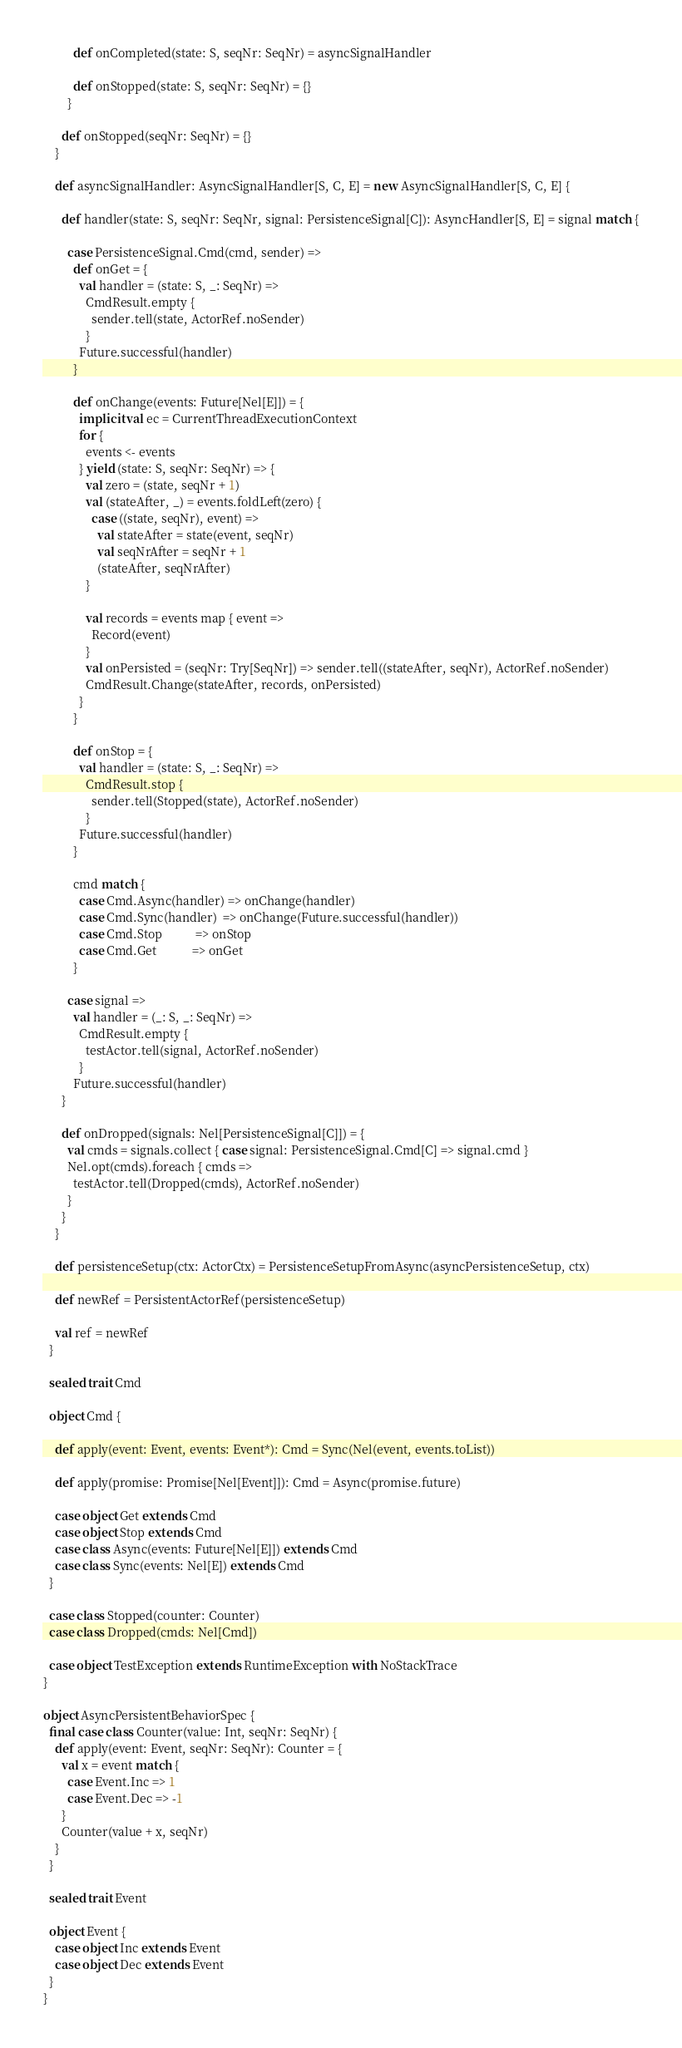<code> <loc_0><loc_0><loc_500><loc_500><_Scala_>          def onCompleted(state: S, seqNr: SeqNr) = asyncSignalHandler

          def onStopped(state: S, seqNr: SeqNr) = {}
        }

      def onStopped(seqNr: SeqNr) = {}
    }

    def asyncSignalHandler: AsyncSignalHandler[S, C, E] = new AsyncSignalHandler[S, C, E] {

      def handler(state: S, seqNr: SeqNr, signal: PersistenceSignal[C]): AsyncHandler[S, E] = signal match {

        case PersistenceSignal.Cmd(cmd, sender) =>
          def onGet = {
            val handler = (state: S, _: SeqNr) =>
              CmdResult.empty {
                sender.tell(state, ActorRef.noSender)
              }
            Future.successful(handler)
          }

          def onChange(events: Future[Nel[E]]) = {
            implicit val ec = CurrentThreadExecutionContext
            for {
              events <- events
            } yield (state: S, seqNr: SeqNr) => {
              val zero = (state, seqNr + 1)
              val (stateAfter, _) = events.foldLeft(zero) {
                case ((state, seqNr), event) =>
                  val stateAfter = state(event, seqNr)
                  val seqNrAfter = seqNr + 1
                  (stateAfter, seqNrAfter)
              }

              val records = events map { event =>
                Record(event)
              }
              val onPersisted = (seqNr: Try[SeqNr]) => sender.tell((stateAfter, seqNr), ActorRef.noSender)
              CmdResult.Change(stateAfter, records, onPersisted)
            }
          }

          def onStop = {
            val handler = (state: S, _: SeqNr) =>
              CmdResult.stop {
                sender.tell(Stopped(state), ActorRef.noSender)
              }
            Future.successful(handler)
          }

          cmd match {
            case Cmd.Async(handler) => onChange(handler)
            case Cmd.Sync(handler)  => onChange(Future.successful(handler))
            case Cmd.Stop           => onStop
            case Cmd.Get            => onGet
          }

        case signal =>
          val handler = (_: S, _: SeqNr) =>
            CmdResult.empty {
              testActor.tell(signal, ActorRef.noSender)
            }
          Future.successful(handler)
      }

      def onDropped(signals: Nel[PersistenceSignal[C]]) = {
        val cmds = signals.collect { case signal: PersistenceSignal.Cmd[C] => signal.cmd }
        Nel.opt(cmds).foreach { cmds =>
          testActor.tell(Dropped(cmds), ActorRef.noSender)
        }
      }
    }

    def persistenceSetup(ctx: ActorCtx) = PersistenceSetupFromAsync(asyncPersistenceSetup, ctx)

    def newRef = PersistentActorRef(persistenceSetup)

    val ref = newRef
  }

  sealed trait Cmd

  object Cmd {

    def apply(event: Event, events: Event*): Cmd = Sync(Nel(event, events.toList))

    def apply(promise: Promise[Nel[Event]]): Cmd = Async(promise.future)

    case object Get extends Cmd
    case object Stop extends Cmd
    case class Async(events: Future[Nel[E]]) extends Cmd
    case class Sync(events: Nel[E]) extends Cmd
  }

  case class Stopped(counter: Counter)
  case class Dropped(cmds: Nel[Cmd])

  case object TestException extends RuntimeException with NoStackTrace
}

object AsyncPersistentBehaviorSpec {
  final case class Counter(value: Int, seqNr: SeqNr) {
    def apply(event: Event, seqNr: SeqNr): Counter = {
      val x = event match {
        case Event.Inc => 1
        case Event.Dec => -1
      }
      Counter(value + x, seqNr)
    }
  }

  sealed trait Event

  object Event {
    case object Inc extends Event
    case object Dec extends Event
  }
}
</code> 